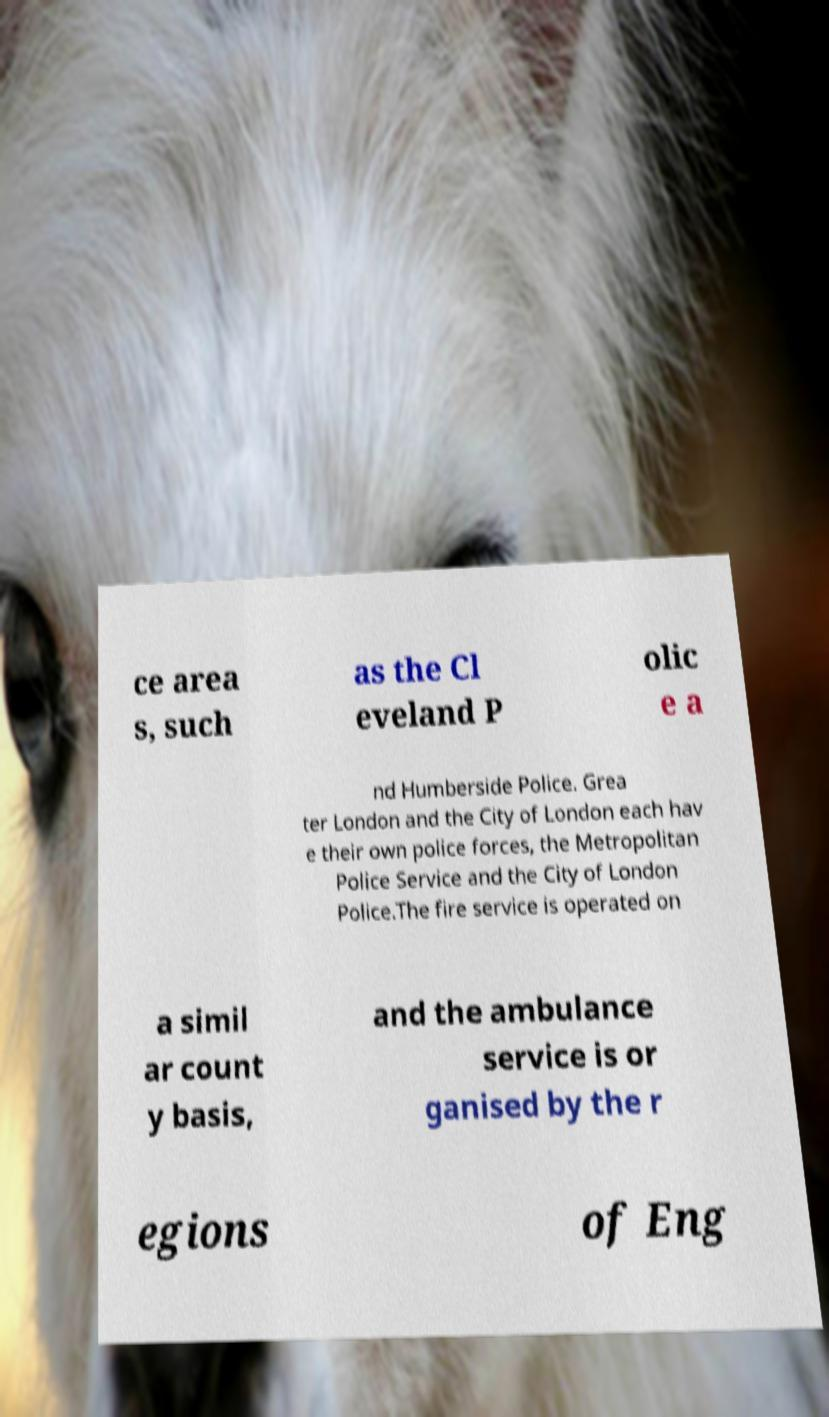There's text embedded in this image that I need extracted. Can you transcribe it verbatim? ce area s, such as the Cl eveland P olic e a nd Humberside Police. Grea ter London and the City of London each hav e their own police forces, the Metropolitan Police Service and the City of London Police.The fire service is operated on a simil ar count y basis, and the ambulance service is or ganised by the r egions of Eng 